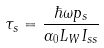<formula> <loc_0><loc_0><loc_500><loc_500>\tau _ { s } = \frac { \hbar { \omega } p _ { s } } { \alpha _ { 0 } L _ { W } I _ { s s } }</formula> 